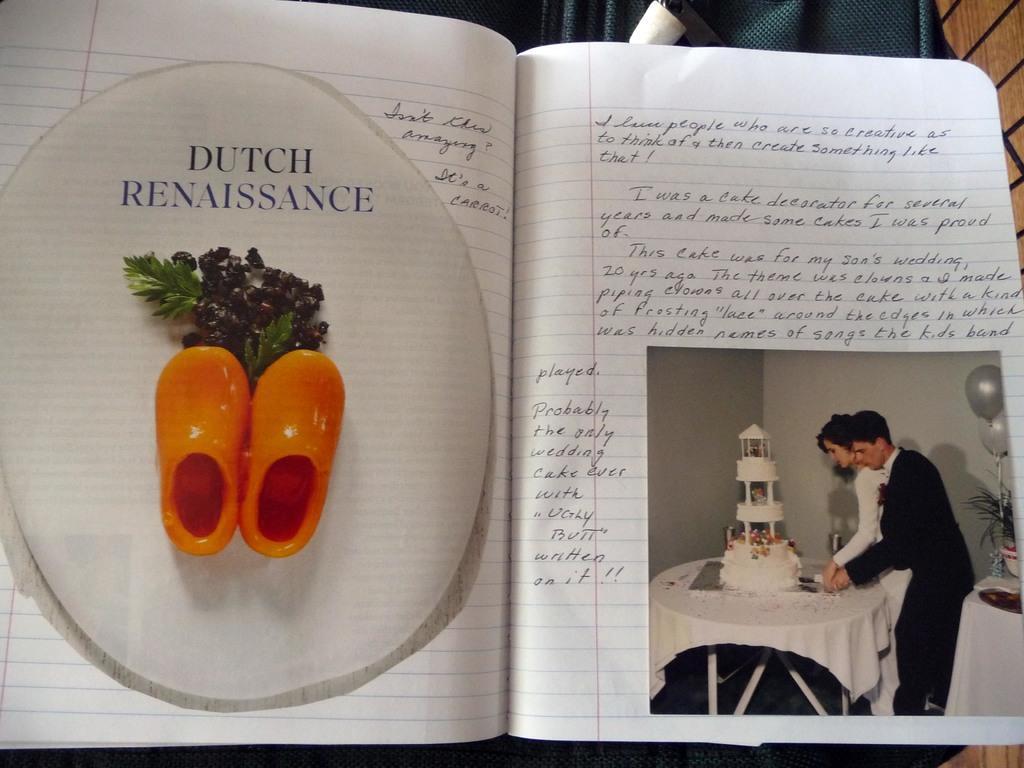In one or two sentences, can you explain what this image depicts? In the picture we can see a book, in that some information is written and some painting with a picture of man and woman cutting the cake on the table. 